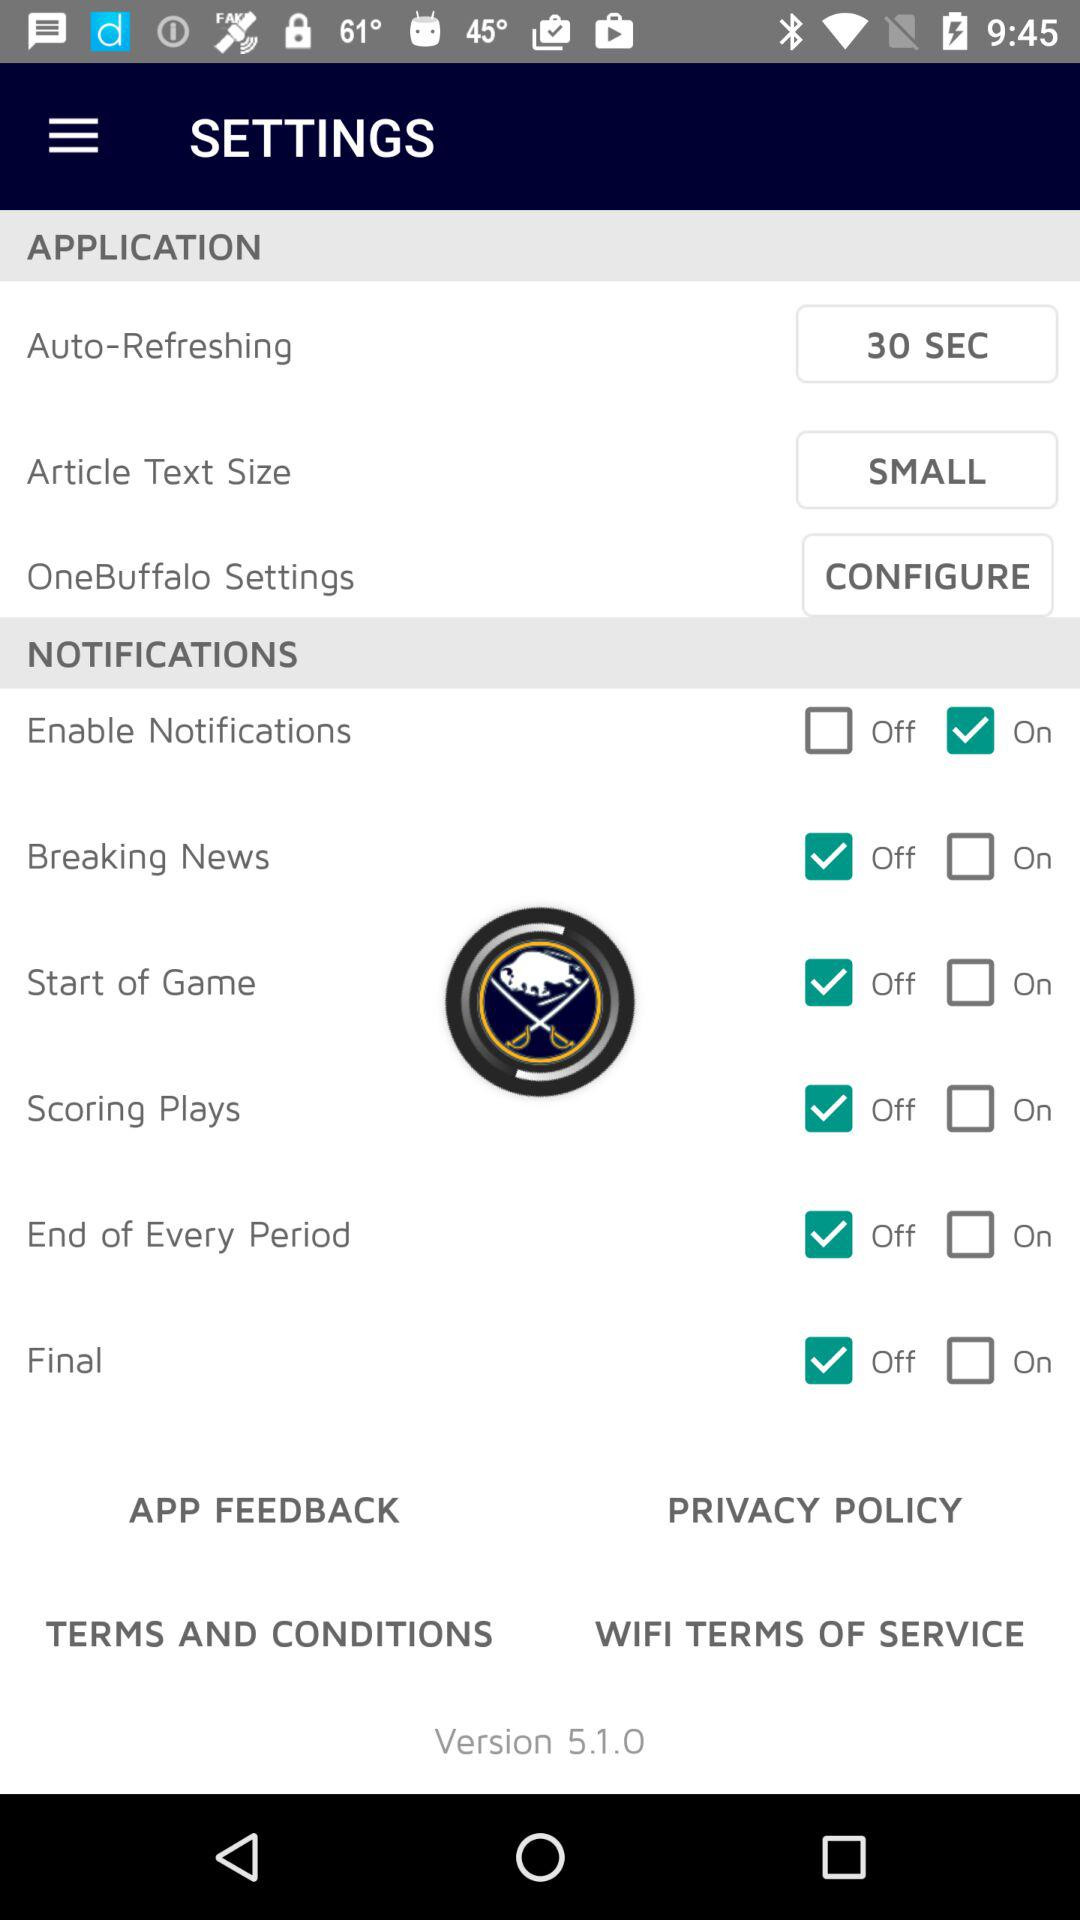What is the application version? The version is 5.1.0. 